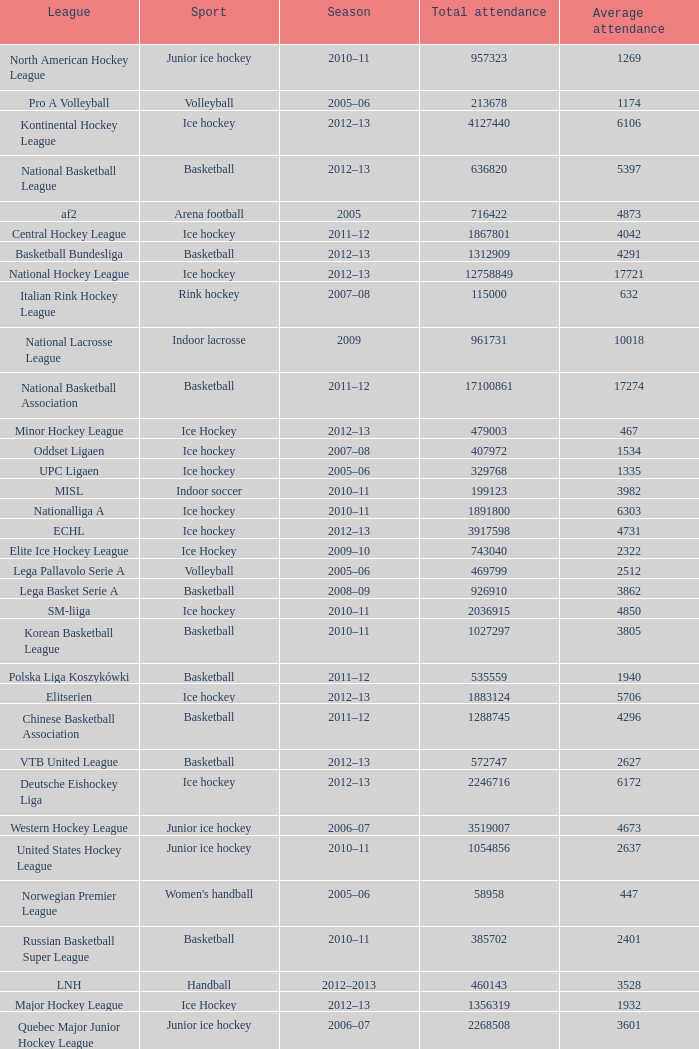What's the average attendance of the league with a total attendance of 2268508? 3601.0. 